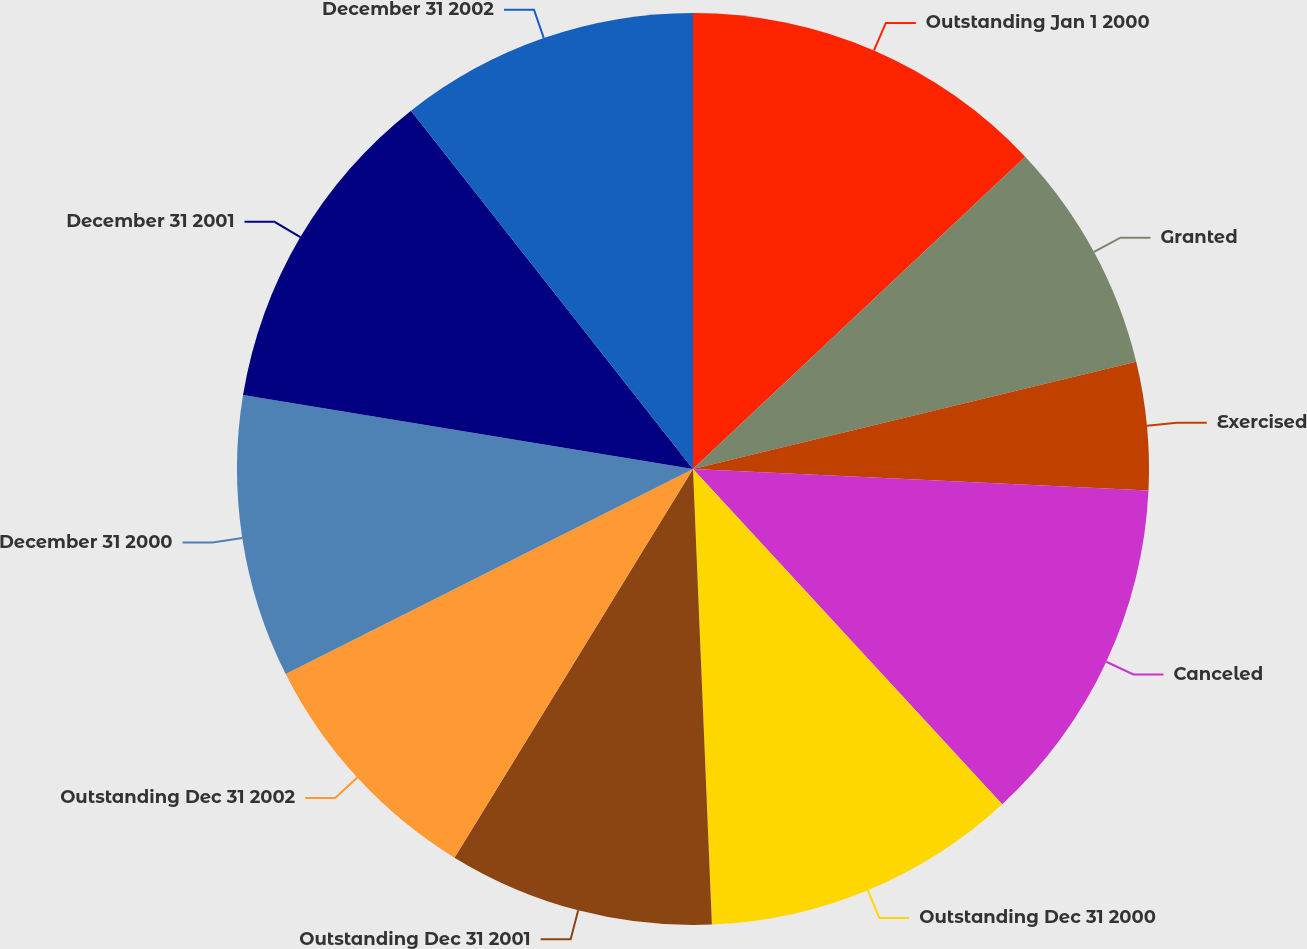<chart> <loc_0><loc_0><loc_500><loc_500><pie_chart><fcel>Outstanding Jan 1 2000<fcel>Granted<fcel>Exercised<fcel>Canceled<fcel>Outstanding Dec 31 2000<fcel>Outstanding Dec 31 2001<fcel>Outstanding Dec 31 2002<fcel>December 31 2000<fcel>December 31 2001<fcel>December 31 2002<nl><fcel>12.99%<fcel>8.23%<fcel>4.53%<fcel>12.39%<fcel>11.2%<fcel>9.42%<fcel>8.82%<fcel>10.01%<fcel>11.8%<fcel>10.61%<nl></chart> 